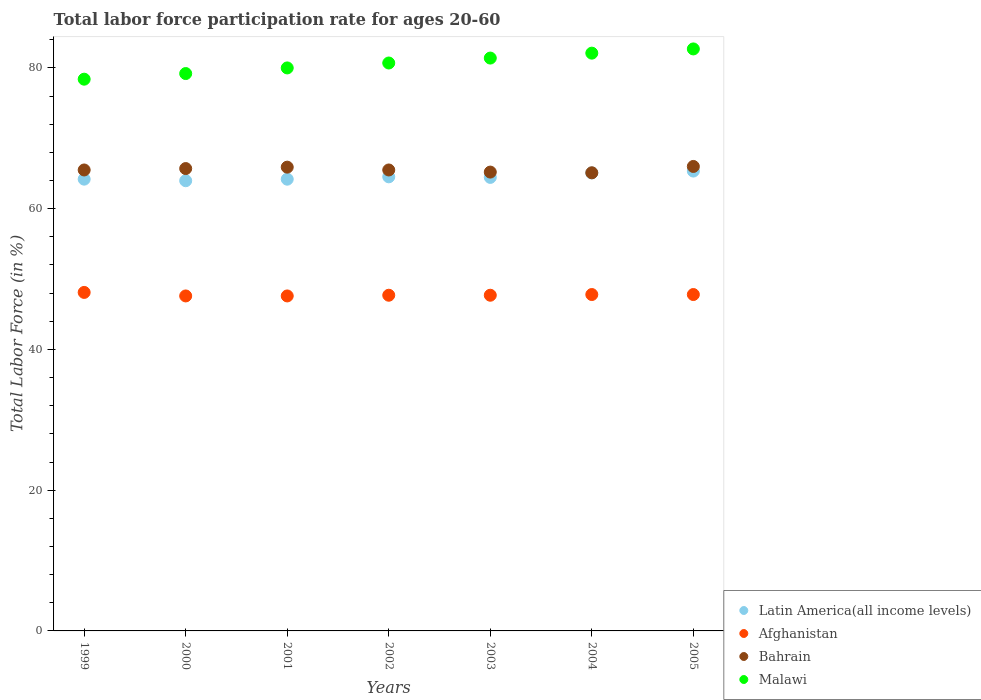How many different coloured dotlines are there?
Offer a very short reply. 4. Is the number of dotlines equal to the number of legend labels?
Your answer should be compact. Yes. What is the labor force participation rate in Bahrain in 2003?
Ensure brevity in your answer.  65.2. Across all years, what is the maximum labor force participation rate in Afghanistan?
Your response must be concise. 48.1. Across all years, what is the minimum labor force participation rate in Bahrain?
Make the answer very short. 65.1. In which year was the labor force participation rate in Latin America(all income levels) maximum?
Keep it short and to the point. 2005. In which year was the labor force participation rate in Malawi minimum?
Provide a short and direct response. 1999. What is the total labor force participation rate in Bahrain in the graph?
Your answer should be compact. 458.9. What is the difference between the labor force participation rate in Bahrain in 1999 and that in 2004?
Offer a very short reply. 0.4. What is the difference between the labor force participation rate in Malawi in 2004 and the labor force participation rate in Bahrain in 2001?
Offer a very short reply. 16.2. What is the average labor force participation rate in Afghanistan per year?
Ensure brevity in your answer.  47.76. In the year 2001, what is the difference between the labor force participation rate in Latin America(all income levels) and labor force participation rate in Afghanistan?
Make the answer very short. 16.59. What is the ratio of the labor force participation rate in Malawi in 2003 to that in 2004?
Provide a short and direct response. 0.99. Is the difference between the labor force participation rate in Latin America(all income levels) in 2001 and 2002 greater than the difference between the labor force participation rate in Afghanistan in 2001 and 2002?
Offer a very short reply. No. What is the difference between the highest and the second highest labor force participation rate in Bahrain?
Provide a succinct answer. 0.1. In how many years, is the labor force participation rate in Latin America(all income levels) greater than the average labor force participation rate in Latin America(all income levels) taken over all years?
Your answer should be very brief. 2. Is the sum of the labor force participation rate in Malawi in 1999 and 2002 greater than the maximum labor force participation rate in Latin America(all income levels) across all years?
Provide a short and direct response. Yes. How many dotlines are there?
Provide a short and direct response. 4. Are the values on the major ticks of Y-axis written in scientific E-notation?
Give a very brief answer. No. Does the graph contain any zero values?
Your answer should be compact. No. Does the graph contain grids?
Make the answer very short. No. How many legend labels are there?
Provide a short and direct response. 4. What is the title of the graph?
Your response must be concise. Total labor force participation rate for ages 20-60. Does "Ghana" appear as one of the legend labels in the graph?
Your answer should be compact. No. What is the label or title of the Y-axis?
Make the answer very short. Total Labor Force (in %). What is the Total Labor Force (in %) of Latin America(all income levels) in 1999?
Your answer should be compact. 64.19. What is the Total Labor Force (in %) in Afghanistan in 1999?
Keep it short and to the point. 48.1. What is the Total Labor Force (in %) in Bahrain in 1999?
Your answer should be compact. 65.5. What is the Total Labor Force (in %) in Malawi in 1999?
Your response must be concise. 78.4. What is the Total Labor Force (in %) in Latin America(all income levels) in 2000?
Provide a succinct answer. 63.97. What is the Total Labor Force (in %) in Afghanistan in 2000?
Your answer should be compact. 47.6. What is the Total Labor Force (in %) of Bahrain in 2000?
Your answer should be compact. 65.7. What is the Total Labor Force (in %) in Malawi in 2000?
Keep it short and to the point. 79.2. What is the Total Labor Force (in %) in Latin America(all income levels) in 2001?
Your answer should be compact. 64.19. What is the Total Labor Force (in %) of Afghanistan in 2001?
Give a very brief answer. 47.6. What is the Total Labor Force (in %) in Bahrain in 2001?
Your response must be concise. 65.9. What is the Total Labor Force (in %) in Malawi in 2001?
Provide a succinct answer. 80. What is the Total Labor Force (in %) in Latin America(all income levels) in 2002?
Ensure brevity in your answer.  64.53. What is the Total Labor Force (in %) of Afghanistan in 2002?
Make the answer very short. 47.7. What is the Total Labor Force (in %) of Bahrain in 2002?
Your answer should be compact. 65.5. What is the Total Labor Force (in %) of Malawi in 2002?
Ensure brevity in your answer.  80.7. What is the Total Labor Force (in %) of Latin America(all income levels) in 2003?
Your answer should be very brief. 64.44. What is the Total Labor Force (in %) in Afghanistan in 2003?
Your answer should be very brief. 47.7. What is the Total Labor Force (in %) of Bahrain in 2003?
Ensure brevity in your answer.  65.2. What is the Total Labor Force (in %) in Malawi in 2003?
Ensure brevity in your answer.  81.4. What is the Total Labor Force (in %) of Latin America(all income levels) in 2004?
Provide a succinct answer. 65.08. What is the Total Labor Force (in %) of Afghanistan in 2004?
Offer a very short reply. 47.8. What is the Total Labor Force (in %) in Bahrain in 2004?
Ensure brevity in your answer.  65.1. What is the Total Labor Force (in %) in Malawi in 2004?
Your response must be concise. 82.1. What is the Total Labor Force (in %) of Latin America(all income levels) in 2005?
Your response must be concise. 65.34. What is the Total Labor Force (in %) in Afghanistan in 2005?
Keep it short and to the point. 47.8. What is the Total Labor Force (in %) of Malawi in 2005?
Give a very brief answer. 82.7. Across all years, what is the maximum Total Labor Force (in %) in Latin America(all income levels)?
Keep it short and to the point. 65.34. Across all years, what is the maximum Total Labor Force (in %) in Afghanistan?
Offer a very short reply. 48.1. Across all years, what is the maximum Total Labor Force (in %) of Bahrain?
Make the answer very short. 66. Across all years, what is the maximum Total Labor Force (in %) in Malawi?
Offer a terse response. 82.7. Across all years, what is the minimum Total Labor Force (in %) in Latin America(all income levels)?
Make the answer very short. 63.97. Across all years, what is the minimum Total Labor Force (in %) in Afghanistan?
Offer a very short reply. 47.6. Across all years, what is the minimum Total Labor Force (in %) in Bahrain?
Provide a short and direct response. 65.1. Across all years, what is the minimum Total Labor Force (in %) of Malawi?
Offer a very short reply. 78.4. What is the total Total Labor Force (in %) of Latin America(all income levels) in the graph?
Provide a succinct answer. 451.75. What is the total Total Labor Force (in %) in Afghanistan in the graph?
Give a very brief answer. 334.3. What is the total Total Labor Force (in %) in Bahrain in the graph?
Provide a succinct answer. 458.9. What is the total Total Labor Force (in %) of Malawi in the graph?
Offer a very short reply. 564.5. What is the difference between the Total Labor Force (in %) in Latin America(all income levels) in 1999 and that in 2000?
Keep it short and to the point. 0.22. What is the difference between the Total Labor Force (in %) of Latin America(all income levels) in 1999 and that in 2001?
Offer a very short reply. 0. What is the difference between the Total Labor Force (in %) of Bahrain in 1999 and that in 2001?
Your response must be concise. -0.4. What is the difference between the Total Labor Force (in %) of Malawi in 1999 and that in 2001?
Your response must be concise. -1.6. What is the difference between the Total Labor Force (in %) of Latin America(all income levels) in 1999 and that in 2002?
Offer a terse response. -0.33. What is the difference between the Total Labor Force (in %) in Bahrain in 1999 and that in 2002?
Your response must be concise. 0. What is the difference between the Total Labor Force (in %) of Malawi in 1999 and that in 2002?
Keep it short and to the point. -2.3. What is the difference between the Total Labor Force (in %) of Latin America(all income levels) in 1999 and that in 2003?
Give a very brief answer. -0.25. What is the difference between the Total Labor Force (in %) in Bahrain in 1999 and that in 2003?
Your response must be concise. 0.3. What is the difference between the Total Labor Force (in %) of Latin America(all income levels) in 1999 and that in 2004?
Make the answer very short. -0.88. What is the difference between the Total Labor Force (in %) in Bahrain in 1999 and that in 2004?
Your answer should be compact. 0.4. What is the difference between the Total Labor Force (in %) in Malawi in 1999 and that in 2004?
Your answer should be very brief. -3.7. What is the difference between the Total Labor Force (in %) in Latin America(all income levels) in 1999 and that in 2005?
Offer a terse response. -1.15. What is the difference between the Total Labor Force (in %) in Afghanistan in 1999 and that in 2005?
Make the answer very short. 0.3. What is the difference between the Total Labor Force (in %) of Bahrain in 1999 and that in 2005?
Your response must be concise. -0.5. What is the difference between the Total Labor Force (in %) of Malawi in 1999 and that in 2005?
Provide a short and direct response. -4.3. What is the difference between the Total Labor Force (in %) in Latin America(all income levels) in 2000 and that in 2001?
Offer a very short reply. -0.22. What is the difference between the Total Labor Force (in %) of Latin America(all income levels) in 2000 and that in 2002?
Give a very brief answer. -0.55. What is the difference between the Total Labor Force (in %) of Afghanistan in 2000 and that in 2002?
Provide a succinct answer. -0.1. What is the difference between the Total Labor Force (in %) of Bahrain in 2000 and that in 2002?
Your answer should be very brief. 0.2. What is the difference between the Total Labor Force (in %) of Malawi in 2000 and that in 2002?
Your response must be concise. -1.5. What is the difference between the Total Labor Force (in %) in Latin America(all income levels) in 2000 and that in 2003?
Offer a very short reply. -0.47. What is the difference between the Total Labor Force (in %) of Bahrain in 2000 and that in 2003?
Give a very brief answer. 0.5. What is the difference between the Total Labor Force (in %) in Latin America(all income levels) in 2000 and that in 2004?
Provide a succinct answer. -1.1. What is the difference between the Total Labor Force (in %) in Latin America(all income levels) in 2000 and that in 2005?
Give a very brief answer. -1.37. What is the difference between the Total Labor Force (in %) in Afghanistan in 2000 and that in 2005?
Make the answer very short. -0.2. What is the difference between the Total Labor Force (in %) of Bahrain in 2000 and that in 2005?
Your answer should be very brief. -0.3. What is the difference between the Total Labor Force (in %) in Latin America(all income levels) in 2001 and that in 2002?
Give a very brief answer. -0.34. What is the difference between the Total Labor Force (in %) in Afghanistan in 2001 and that in 2002?
Your response must be concise. -0.1. What is the difference between the Total Labor Force (in %) of Bahrain in 2001 and that in 2002?
Provide a short and direct response. 0.4. What is the difference between the Total Labor Force (in %) of Latin America(all income levels) in 2001 and that in 2003?
Give a very brief answer. -0.25. What is the difference between the Total Labor Force (in %) in Afghanistan in 2001 and that in 2003?
Your answer should be compact. -0.1. What is the difference between the Total Labor Force (in %) in Malawi in 2001 and that in 2003?
Your answer should be very brief. -1.4. What is the difference between the Total Labor Force (in %) in Latin America(all income levels) in 2001 and that in 2004?
Your response must be concise. -0.88. What is the difference between the Total Labor Force (in %) of Bahrain in 2001 and that in 2004?
Your answer should be very brief. 0.8. What is the difference between the Total Labor Force (in %) of Latin America(all income levels) in 2001 and that in 2005?
Keep it short and to the point. -1.15. What is the difference between the Total Labor Force (in %) in Afghanistan in 2001 and that in 2005?
Make the answer very short. -0.2. What is the difference between the Total Labor Force (in %) of Bahrain in 2001 and that in 2005?
Offer a terse response. -0.1. What is the difference between the Total Labor Force (in %) in Malawi in 2001 and that in 2005?
Provide a short and direct response. -2.7. What is the difference between the Total Labor Force (in %) of Latin America(all income levels) in 2002 and that in 2003?
Your answer should be very brief. 0.08. What is the difference between the Total Labor Force (in %) in Bahrain in 2002 and that in 2003?
Offer a terse response. 0.3. What is the difference between the Total Labor Force (in %) in Malawi in 2002 and that in 2003?
Offer a very short reply. -0.7. What is the difference between the Total Labor Force (in %) of Latin America(all income levels) in 2002 and that in 2004?
Your answer should be compact. -0.55. What is the difference between the Total Labor Force (in %) of Afghanistan in 2002 and that in 2004?
Your response must be concise. -0.1. What is the difference between the Total Labor Force (in %) in Bahrain in 2002 and that in 2004?
Provide a succinct answer. 0.4. What is the difference between the Total Labor Force (in %) of Malawi in 2002 and that in 2004?
Ensure brevity in your answer.  -1.4. What is the difference between the Total Labor Force (in %) in Latin America(all income levels) in 2002 and that in 2005?
Provide a succinct answer. -0.82. What is the difference between the Total Labor Force (in %) of Afghanistan in 2002 and that in 2005?
Your answer should be very brief. -0.1. What is the difference between the Total Labor Force (in %) of Bahrain in 2002 and that in 2005?
Your answer should be compact. -0.5. What is the difference between the Total Labor Force (in %) in Malawi in 2002 and that in 2005?
Your answer should be compact. -2. What is the difference between the Total Labor Force (in %) of Latin America(all income levels) in 2003 and that in 2004?
Make the answer very short. -0.63. What is the difference between the Total Labor Force (in %) in Afghanistan in 2003 and that in 2004?
Provide a succinct answer. -0.1. What is the difference between the Total Labor Force (in %) in Latin America(all income levels) in 2003 and that in 2005?
Provide a succinct answer. -0.9. What is the difference between the Total Labor Force (in %) in Afghanistan in 2003 and that in 2005?
Your response must be concise. -0.1. What is the difference between the Total Labor Force (in %) of Bahrain in 2003 and that in 2005?
Provide a succinct answer. -0.8. What is the difference between the Total Labor Force (in %) in Latin America(all income levels) in 2004 and that in 2005?
Keep it short and to the point. -0.27. What is the difference between the Total Labor Force (in %) of Bahrain in 2004 and that in 2005?
Your answer should be very brief. -0.9. What is the difference between the Total Labor Force (in %) in Malawi in 2004 and that in 2005?
Your answer should be very brief. -0.6. What is the difference between the Total Labor Force (in %) of Latin America(all income levels) in 1999 and the Total Labor Force (in %) of Afghanistan in 2000?
Keep it short and to the point. 16.59. What is the difference between the Total Labor Force (in %) of Latin America(all income levels) in 1999 and the Total Labor Force (in %) of Bahrain in 2000?
Offer a terse response. -1.51. What is the difference between the Total Labor Force (in %) of Latin America(all income levels) in 1999 and the Total Labor Force (in %) of Malawi in 2000?
Your answer should be compact. -15.01. What is the difference between the Total Labor Force (in %) of Afghanistan in 1999 and the Total Labor Force (in %) of Bahrain in 2000?
Offer a terse response. -17.6. What is the difference between the Total Labor Force (in %) of Afghanistan in 1999 and the Total Labor Force (in %) of Malawi in 2000?
Offer a terse response. -31.1. What is the difference between the Total Labor Force (in %) of Bahrain in 1999 and the Total Labor Force (in %) of Malawi in 2000?
Your answer should be compact. -13.7. What is the difference between the Total Labor Force (in %) in Latin America(all income levels) in 1999 and the Total Labor Force (in %) in Afghanistan in 2001?
Your answer should be very brief. 16.59. What is the difference between the Total Labor Force (in %) of Latin America(all income levels) in 1999 and the Total Labor Force (in %) of Bahrain in 2001?
Provide a short and direct response. -1.71. What is the difference between the Total Labor Force (in %) in Latin America(all income levels) in 1999 and the Total Labor Force (in %) in Malawi in 2001?
Offer a very short reply. -15.81. What is the difference between the Total Labor Force (in %) of Afghanistan in 1999 and the Total Labor Force (in %) of Bahrain in 2001?
Provide a short and direct response. -17.8. What is the difference between the Total Labor Force (in %) of Afghanistan in 1999 and the Total Labor Force (in %) of Malawi in 2001?
Offer a very short reply. -31.9. What is the difference between the Total Labor Force (in %) in Bahrain in 1999 and the Total Labor Force (in %) in Malawi in 2001?
Offer a very short reply. -14.5. What is the difference between the Total Labor Force (in %) in Latin America(all income levels) in 1999 and the Total Labor Force (in %) in Afghanistan in 2002?
Make the answer very short. 16.49. What is the difference between the Total Labor Force (in %) in Latin America(all income levels) in 1999 and the Total Labor Force (in %) in Bahrain in 2002?
Your answer should be compact. -1.31. What is the difference between the Total Labor Force (in %) in Latin America(all income levels) in 1999 and the Total Labor Force (in %) in Malawi in 2002?
Offer a terse response. -16.51. What is the difference between the Total Labor Force (in %) of Afghanistan in 1999 and the Total Labor Force (in %) of Bahrain in 2002?
Provide a succinct answer. -17.4. What is the difference between the Total Labor Force (in %) of Afghanistan in 1999 and the Total Labor Force (in %) of Malawi in 2002?
Your answer should be very brief. -32.6. What is the difference between the Total Labor Force (in %) in Bahrain in 1999 and the Total Labor Force (in %) in Malawi in 2002?
Offer a very short reply. -15.2. What is the difference between the Total Labor Force (in %) of Latin America(all income levels) in 1999 and the Total Labor Force (in %) of Afghanistan in 2003?
Ensure brevity in your answer.  16.49. What is the difference between the Total Labor Force (in %) in Latin America(all income levels) in 1999 and the Total Labor Force (in %) in Bahrain in 2003?
Offer a very short reply. -1.01. What is the difference between the Total Labor Force (in %) in Latin America(all income levels) in 1999 and the Total Labor Force (in %) in Malawi in 2003?
Your response must be concise. -17.21. What is the difference between the Total Labor Force (in %) of Afghanistan in 1999 and the Total Labor Force (in %) of Bahrain in 2003?
Provide a short and direct response. -17.1. What is the difference between the Total Labor Force (in %) of Afghanistan in 1999 and the Total Labor Force (in %) of Malawi in 2003?
Make the answer very short. -33.3. What is the difference between the Total Labor Force (in %) in Bahrain in 1999 and the Total Labor Force (in %) in Malawi in 2003?
Your response must be concise. -15.9. What is the difference between the Total Labor Force (in %) of Latin America(all income levels) in 1999 and the Total Labor Force (in %) of Afghanistan in 2004?
Offer a terse response. 16.39. What is the difference between the Total Labor Force (in %) in Latin America(all income levels) in 1999 and the Total Labor Force (in %) in Bahrain in 2004?
Your answer should be compact. -0.91. What is the difference between the Total Labor Force (in %) in Latin America(all income levels) in 1999 and the Total Labor Force (in %) in Malawi in 2004?
Ensure brevity in your answer.  -17.91. What is the difference between the Total Labor Force (in %) of Afghanistan in 1999 and the Total Labor Force (in %) of Malawi in 2004?
Your answer should be compact. -34. What is the difference between the Total Labor Force (in %) in Bahrain in 1999 and the Total Labor Force (in %) in Malawi in 2004?
Keep it short and to the point. -16.6. What is the difference between the Total Labor Force (in %) of Latin America(all income levels) in 1999 and the Total Labor Force (in %) of Afghanistan in 2005?
Provide a short and direct response. 16.39. What is the difference between the Total Labor Force (in %) in Latin America(all income levels) in 1999 and the Total Labor Force (in %) in Bahrain in 2005?
Provide a short and direct response. -1.81. What is the difference between the Total Labor Force (in %) of Latin America(all income levels) in 1999 and the Total Labor Force (in %) of Malawi in 2005?
Ensure brevity in your answer.  -18.51. What is the difference between the Total Labor Force (in %) of Afghanistan in 1999 and the Total Labor Force (in %) of Bahrain in 2005?
Make the answer very short. -17.9. What is the difference between the Total Labor Force (in %) of Afghanistan in 1999 and the Total Labor Force (in %) of Malawi in 2005?
Give a very brief answer. -34.6. What is the difference between the Total Labor Force (in %) in Bahrain in 1999 and the Total Labor Force (in %) in Malawi in 2005?
Provide a short and direct response. -17.2. What is the difference between the Total Labor Force (in %) of Latin America(all income levels) in 2000 and the Total Labor Force (in %) of Afghanistan in 2001?
Provide a short and direct response. 16.37. What is the difference between the Total Labor Force (in %) of Latin America(all income levels) in 2000 and the Total Labor Force (in %) of Bahrain in 2001?
Your response must be concise. -1.93. What is the difference between the Total Labor Force (in %) of Latin America(all income levels) in 2000 and the Total Labor Force (in %) of Malawi in 2001?
Your answer should be very brief. -16.03. What is the difference between the Total Labor Force (in %) in Afghanistan in 2000 and the Total Labor Force (in %) in Bahrain in 2001?
Keep it short and to the point. -18.3. What is the difference between the Total Labor Force (in %) in Afghanistan in 2000 and the Total Labor Force (in %) in Malawi in 2001?
Provide a short and direct response. -32.4. What is the difference between the Total Labor Force (in %) of Bahrain in 2000 and the Total Labor Force (in %) of Malawi in 2001?
Your response must be concise. -14.3. What is the difference between the Total Labor Force (in %) of Latin America(all income levels) in 2000 and the Total Labor Force (in %) of Afghanistan in 2002?
Offer a very short reply. 16.27. What is the difference between the Total Labor Force (in %) of Latin America(all income levels) in 2000 and the Total Labor Force (in %) of Bahrain in 2002?
Provide a short and direct response. -1.53. What is the difference between the Total Labor Force (in %) in Latin America(all income levels) in 2000 and the Total Labor Force (in %) in Malawi in 2002?
Your answer should be very brief. -16.73. What is the difference between the Total Labor Force (in %) in Afghanistan in 2000 and the Total Labor Force (in %) in Bahrain in 2002?
Provide a short and direct response. -17.9. What is the difference between the Total Labor Force (in %) in Afghanistan in 2000 and the Total Labor Force (in %) in Malawi in 2002?
Provide a short and direct response. -33.1. What is the difference between the Total Labor Force (in %) in Latin America(all income levels) in 2000 and the Total Labor Force (in %) in Afghanistan in 2003?
Your response must be concise. 16.27. What is the difference between the Total Labor Force (in %) in Latin America(all income levels) in 2000 and the Total Labor Force (in %) in Bahrain in 2003?
Ensure brevity in your answer.  -1.23. What is the difference between the Total Labor Force (in %) in Latin America(all income levels) in 2000 and the Total Labor Force (in %) in Malawi in 2003?
Give a very brief answer. -17.43. What is the difference between the Total Labor Force (in %) of Afghanistan in 2000 and the Total Labor Force (in %) of Bahrain in 2003?
Your response must be concise. -17.6. What is the difference between the Total Labor Force (in %) in Afghanistan in 2000 and the Total Labor Force (in %) in Malawi in 2003?
Your answer should be compact. -33.8. What is the difference between the Total Labor Force (in %) of Bahrain in 2000 and the Total Labor Force (in %) of Malawi in 2003?
Your answer should be compact. -15.7. What is the difference between the Total Labor Force (in %) in Latin America(all income levels) in 2000 and the Total Labor Force (in %) in Afghanistan in 2004?
Offer a very short reply. 16.17. What is the difference between the Total Labor Force (in %) in Latin America(all income levels) in 2000 and the Total Labor Force (in %) in Bahrain in 2004?
Provide a succinct answer. -1.13. What is the difference between the Total Labor Force (in %) in Latin America(all income levels) in 2000 and the Total Labor Force (in %) in Malawi in 2004?
Ensure brevity in your answer.  -18.13. What is the difference between the Total Labor Force (in %) in Afghanistan in 2000 and the Total Labor Force (in %) in Bahrain in 2004?
Offer a terse response. -17.5. What is the difference between the Total Labor Force (in %) in Afghanistan in 2000 and the Total Labor Force (in %) in Malawi in 2004?
Provide a succinct answer. -34.5. What is the difference between the Total Labor Force (in %) in Bahrain in 2000 and the Total Labor Force (in %) in Malawi in 2004?
Your answer should be compact. -16.4. What is the difference between the Total Labor Force (in %) of Latin America(all income levels) in 2000 and the Total Labor Force (in %) of Afghanistan in 2005?
Your answer should be compact. 16.17. What is the difference between the Total Labor Force (in %) of Latin America(all income levels) in 2000 and the Total Labor Force (in %) of Bahrain in 2005?
Give a very brief answer. -2.03. What is the difference between the Total Labor Force (in %) in Latin America(all income levels) in 2000 and the Total Labor Force (in %) in Malawi in 2005?
Keep it short and to the point. -18.73. What is the difference between the Total Labor Force (in %) of Afghanistan in 2000 and the Total Labor Force (in %) of Bahrain in 2005?
Make the answer very short. -18.4. What is the difference between the Total Labor Force (in %) of Afghanistan in 2000 and the Total Labor Force (in %) of Malawi in 2005?
Provide a succinct answer. -35.1. What is the difference between the Total Labor Force (in %) of Latin America(all income levels) in 2001 and the Total Labor Force (in %) of Afghanistan in 2002?
Keep it short and to the point. 16.49. What is the difference between the Total Labor Force (in %) in Latin America(all income levels) in 2001 and the Total Labor Force (in %) in Bahrain in 2002?
Make the answer very short. -1.31. What is the difference between the Total Labor Force (in %) in Latin America(all income levels) in 2001 and the Total Labor Force (in %) in Malawi in 2002?
Your answer should be very brief. -16.51. What is the difference between the Total Labor Force (in %) in Afghanistan in 2001 and the Total Labor Force (in %) in Bahrain in 2002?
Keep it short and to the point. -17.9. What is the difference between the Total Labor Force (in %) of Afghanistan in 2001 and the Total Labor Force (in %) of Malawi in 2002?
Your answer should be compact. -33.1. What is the difference between the Total Labor Force (in %) of Bahrain in 2001 and the Total Labor Force (in %) of Malawi in 2002?
Your response must be concise. -14.8. What is the difference between the Total Labor Force (in %) of Latin America(all income levels) in 2001 and the Total Labor Force (in %) of Afghanistan in 2003?
Offer a terse response. 16.49. What is the difference between the Total Labor Force (in %) of Latin America(all income levels) in 2001 and the Total Labor Force (in %) of Bahrain in 2003?
Keep it short and to the point. -1.01. What is the difference between the Total Labor Force (in %) of Latin America(all income levels) in 2001 and the Total Labor Force (in %) of Malawi in 2003?
Your answer should be compact. -17.21. What is the difference between the Total Labor Force (in %) in Afghanistan in 2001 and the Total Labor Force (in %) in Bahrain in 2003?
Give a very brief answer. -17.6. What is the difference between the Total Labor Force (in %) of Afghanistan in 2001 and the Total Labor Force (in %) of Malawi in 2003?
Keep it short and to the point. -33.8. What is the difference between the Total Labor Force (in %) in Bahrain in 2001 and the Total Labor Force (in %) in Malawi in 2003?
Keep it short and to the point. -15.5. What is the difference between the Total Labor Force (in %) of Latin America(all income levels) in 2001 and the Total Labor Force (in %) of Afghanistan in 2004?
Your response must be concise. 16.39. What is the difference between the Total Labor Force (in %) in Latin America(all income levels) in 2001 and the Total Labor Force (in %) in Bahrain in 2004?
Offer a terse response. -0.91. What is the difference between the Total Labor Force (in %) of Latin America(all income levels) in 2001 and the Total Labor Force (in %) of Malawi in 2004?
Offer a terse response. -17.91. What is the difference between the Total Labor Force (in %) of Afghanistan in 2001 and the Total Labor Force (in %) of Bahrain in 2004?
Keep it short and to the point. -17.5. What is the difference between the Total Labor Force (in %) in Afghanistan in 2001 and the Total Labor Force (in %) in Malawi in 2004?
Ensure brevity in your answer.  -34.5. What is the difference between the Total Labor Force (in %) in Bahrain in 2001 and the Total Labor Force (in %) in Malawi in 2004?
Provide a short and direct response. -16.2. What is the difference between the Total Labor Force (in %) of Latin America(all income levels) in 2001 and the Total Labor Force (in %) of Afghanistan in 2005?
Offer a terse response. 16.39. What is the difference between the Total Labor Force (in %) of Latin America(all income levels) in 2001 and the Total Labor Force (in %) of Bahrain in 2005?
Make the answer very short. -1.81. What is the difference between the Total Labor Force (in %) in Latin America(all income levels) in 2001 and the Total Labor Force (in %) in Malawi in 2005?
Your answer should be very brief. -18.51. What is the difference between the Total Labor Force (in %) in Afghanistan in 2001 and the Total Labor Force (in %) in Bahrain in 2005?
Keep it short and to the point. -18.4. What is the difference between the Total Labor Force (in %) in Afghanistan in 2001 and the Total Labor Force (in %) in Malawi in 2005?
Provide a short and direct response. -35.1. What is the difference between the Total Labor Force (in %) in Bahrain in 2001 and the Total Labor Force (in %) in Malawi in 2005?
Your response must be concise. -16.8. What is the difference between the Total Labor Force (in %) in Latin America(all income levels) in 2002 and the Total Labor Force (in %) in Afghanistan in 2003?
Make the answer very short. 16.83. What is the difference between the Total Labor Force (in %) in Latin America(all income levels) in 2002 and the Total Labor Force (in %) in Bahrain in 2003?
Make the answer very short. -0.67. What is the difference between the Total Labor Force (in %) of Latin America(all income levels) in 2002 and the Total Labor Force (in %) of Malawi in 2003?
Provide a succinct answer. -16.87. What is the difference between the Total Labor Force (in %) in Afghanistan in 2002 and the Total Labor Force (in %) in Bahrain in 2003?
Provide a succinct answer. -17.5. What is the difference between the Total Labor Force (in %) of Afghanistan in 2002 and the Total Labor Force (in %) of Malawi in 2003?
Ensure brevity in your answer.  -33.7. What is the difference between the Total Labor Force (in %) of Bahrain in 2002 and the Total Labor Force (in %) of Malawi in 2003?
Your response must be concise. -15.9. What is the difference between the Total Labor Force (in %) of Latin America(all income levels) in 2002 and the Total Labor Force (in %) of Afghanistan in 2004?
Ensure brevity in your answer.  16.73. What is the difference between the Total Labor Force (in %) in Latin America(all income levels) in 2002 and the Total Labor Force (in %) in Bahrain in 2004?
Keep it short and to the point. -0.57. What is the difference between the Total Labor Force (in %) of Latin America(all income levels) in 2002 and the Total Labor Force (in %) of Malawi in 2004?
Give a very brief answer. -17.57. What is the difference between the Total Labor Force (in %) in Afghanistan in 2002 and the Total Labor Force (in %) in Bahrain in 2004?
Provide a succinct answer. -17.4. What is the difference between the Total Labor Force (in %) of Afghanistan in 2002 and the Total Labor Force (in %) of Malawi in 2004?
Your answer should be compact. -34.4. What is the difference between the Total Labor Force (in %) in Bahrain in 2002 and the Total Labor Force (in %) in Malawi in 2004?
Give a very brief answer. -16.6. What is the difference between the Total Labor Force (in %) of Latin America(all income levels) in 2002 and the Total Labor Force (in %) of Afghanistan in 2005?
Your answer should be very brief. 16.73. What is the difference between the Total Labor Force (in %) in Latin America(all income levels) in 2002 and the Total Labor Force (in %) in Bahrain in 2005?
Offer a terse response. -1.47. What is the difference between the Total Labor Force (in %) in Latin America(all income levels) in 2002 and the Total Labor Force (in %) in Malawi in 2005?
Offer a terse response. -18.17. What is the difference between the Total Labor Force (in %) of Afghanistan in 2002 and the Total Labor Force (in %) of Bahrain in 2005?
Keep it short and to the point. -18.3. What is the difference between the Total Labor Force (in %) in Afghanistan in 2002 and the Total Labor Force (in %) in Malawi in 2005?
Your answer should be compact. -35. What is the difference between the Total Labor Force (in %) in Bahrain in 2002 and the Total Labor Force (in %) in Malawi in 2005?
Ensure brevity in your answer.  -17.2. What is the difference between the Total Labor Force (in %) of Latin America(all income levels) in 2003 and the Total Labor Force (in %) of Afghanistan in 2004?
Provide a succinct answer. 16.64. What is the difference between the Total Labor Force (in %) in Latin America(all income levels) in 2003 and the Total Labor Force (in %) in Bahrain in 2004?
Offer a very short reply. -0.66. What is the difference between the Total Labor Force (in %) of Latin America(all income levels) in 2003 and the Total Labor Force (in %) of Malawi in 2004?
Keep it short and to the point. -17.66. What is the difference between the Total Labor Force (in %) of Afghanistan in 2003 and the Total Labor Force (in %) of Bahrain in 2004?
Provide a succinct answer. -17.4. What is the difference between the Total Labor Force (in %) in Afghanistan in 2003 and the Total Labor Force (in %) in Malawi in 2004?
Offer a very short reply. -34.4. What is the difference between the Total Labor Force (in %) in Bahrain in 2003 and the Total Labor Force (in %) in Malawi in 2004?
Provide a succinct answer. -16.9. What is the difference between the Total Labor Force (in %) in Latin America(all income levels) in 2003 and the Total Labor Force (in %) in Afghanistan in 2005?
Your answer should be compact. 16.64. What is the difference between the Total Labor Force (in %) of Latin America(all income levels) in 2003 and the Total Labor Force (in %) of Bahrain in 2005?
Offer a very short reply. -1.56. What is the difference between the Total Labor Force (in %) in Latin America(all income levels) in 2003 and the Total Labor Force (in %) in Malawi in 2005?
Provide a succinct answer. -18.26. What is the difference between the Total Labor Force (in %) of Afghanistan in 2003 and the Total Labor Force (in %) of Bahrain in 2005?
Make the answer very short. -18.3. What is the difference between the Total Labor Force (in %) of Afghanistan in 2003 and the Total Labor Force (in %) of Malawi in 2005?
Offer a terse response. -35. What is the difference between the Total Labor Force (in %) of Bahrain in 2003 and the Total Labor Force (in %) of Malawi in 2005?
Offer a terse response. -17.5. What is the difference between the Total Labor Force (in %) of Latin America(all income levels) in 2004 and the Total Labor Force (in %) of Afghanistan in 2005?
Provide a short and direct response. 17.28. What is the difference between the Total Labor Force (in %) in Latin America(all income levels) in 2004 and the Total Labor Force (in %) in Bahrain in 2005?
Provide a succinct answer. -0.92. What is the difference between the Total Labor Force (in %) of Latin America(all income levels) in 2004 and the Total Labor Force (in %) of Malawi in 2005?
Provide a succinct answer. -17.62. What is the difference between the Total Labor Force (in %) in Afghanistan in 2004 and the Total Labor Force (in %) in Bahrain in 2005?
Your response must be concise. -18.2. What is the difference between the Total Labor Force (in %) in Afghanistan in 2004 and the Total Labor Force (in %) in Malawi in 2005?
Offer a terse response. -34.9. What is the difference between the Total Labor Force (in %) of Bahrain in 2004 and the Total Labor Force (in %) of Malawi in 2005?
Provide a succinct answer. -17.6. What is the average Total Labor Force (in %) in Latin America(all income levels) per year?
Offer a terse response. 64.54. What is the average Total Labor Force (in %) in Afghanistan per year?
Keep it short and to the point. 47.76. What is the average Total Labor Force (in %) in Bahrain per year?
Your answer should be very brief. 65.56. What is the average Total Labor Force (in %) of Malawi per year?
Your answer should be very brief. 80.64. In the year 1999, what is the difference between the Total Labor Force (in %) in Latin America(all income levels) and Total Labor Force (in %) in Afghanistan?
Your answer should be compact. 16.09. In the year 1999, what is the difference between the Total Labor Force (in %) in Latin America(all income levels) and Total Labor Force (in %) in Bahrain?
Make the answer very short. -1.31. In the year 1999, what is the difference between the Total Labor Force (in %) in Latin America(all income levels) and Total Labor Force (in %) in Malawi?
Your answer should be very brief. -14.21. In the year 1999, what is the difference between the Total Labor Force (in %) in Afghanistan and Total Labor Force (in %) in Bahrain?
Your answer should be very brief. -17.4. In the year 1999, what is the difference between the Total Labor Force (in %) of Afghanistan and Total Labor Force (in %) of Malawi?
Provide a short and direct response. -30.3. In the year 2000, what is the difference between the Total Labor Force (in %) of Latin America(all income levels) and Total Labor Force (in %) of Afghanistan?
Make the answer very short. 16.37. In the year 2000, what is the difference between the Total Labor Force (in %) of Latin America(all income levels) and Total Labor Force (in %) of Bahrain?
Keep it short and to the point. -1.73. In the year 2000, what is the difference between the Total Labor Force (in %) in Latin America(all income levels) and Total Labor Force (in %) in Malawi?
Provide a succinct answer. -15.23. In the year 2000, what is the difference between the Total Labor Force (in %) of Afghanistan and Total Labor Force (in %) of Bahrain?
Keep it short and to the point. -18.1. In the year 2000, what is the difference between the Total Labor Force (in %) of Afghanistan and Total Labor Force (in %) of Malawi?
Your answer should be very brief. -31.6. In the year 2001, what is the difference between the Total Labor Force (in %) in Latin America(all income levels) and Total Labor Force (in %) in Afghanistan?
Your answer should be very brief. 16.59. In the year 2001, what is the difference between the Total Labor Force (in %) of Latin America(all income levels) and Total Labor Force (in %) of Bahrain?
Keep it short and to the point. -1.71. In the year 2001, what is the difference between the Total Labor Force (in %) in Latin America(all income levels) and Total Labor Force (in %) in Malawi?
Offer a terse response. -15.81. In the year 2001, what is the difference between the Total Labor Force (in %) in Afghanistan and Total Labor Force (in %) in Bahrain?
Provide a succinct answer. -18.3. In the year 2001, what is the difference between the Total Labor Force (in %) of Afghanistan and Total Labor Force (in %) of Malawi?
Your response must be concise. -32.4. In the year 2001, what is the difference between the Total Labor Force (in %) in Bahrain and Total Labor Force (in %) in Malawi?
Keep it short and to the point. -14.1. In the year 2002, what is the difference between the Total Labor Force (in %) in Latin America(all income levels) and Total Labor Force (in %) in Afghanistan?
Make the answer very short. 16.83. In the year 2002, what is the difference between the Total Labor Force (in %) of Latin America(all income levels) and Total Labor Force (in %) of Bahrain?
Provide a short and direct response. -0.97. In the year 2002, what is the difference between the Total Labor Force (in %) of Latin America(all income levels) and Total Labor Force (in %) of Malawi?
Your response must be concise. -16.17. In the year 2002, what is the difference between the Total Labor Force (in %) in Afghanistan and Total Labor Force (in %) in Bahrain?
Your response must be concise. -17.8. In the year 2002, what is the difference between the Total Labor Force (in %) in Afghanistan and Total Labor Force (in %) in Malawi?
Your answer should be compact. -33. In the year 2002, what is the difference between the Total Labor Force (in %) of Bahrain and Total Labor Force (in %) of Malawi?
Your answer should be very brief. -15.2. In the year 2003, what is the difference between the Total Labor Force (in %) of Latin America(all income levels) and Total Labor Force (in %) of Afghanistan?
Provide a short and direct response. 16.74. In the year 2003, what is the difference between the Total Labor Force (in %) of Latin America(all income levels) and Total Labor Force (in %) of Bahrain?
Make the answer very short. -0.76. In the year 2003, what is the difference between the Total Labor Force (in %) in Latin America(all income levels) and Total Labor Force (in %) in Malawi?
Your answer should be compact. -16.96. In the year 2003, what is the difference between the Total Labor Force (in %) of Afghanistan and Total Labor Force (in %) of Bahrain?
Your answer should be very brief. -17.5. In the year 2003, what is the difference between the Total Labor Force (in %) of Afghanistan and Total Labor Force (in %) of Malawi?
Give a very brief answer. -33.7. In the year 2003, what is the difference between the Total Labor Force (in %) in Bahrain and Total Labor Force (in %) in Malawi?
Give a very brief answer. -16.2. In the year 2004, what is the difference between the Total Labor Force (in %) of Latin America(all income levels) and Total Labor Force (in %) of Afghanistan?
Keep it short and to the point. 17.28. In the year 2004, what is the difference between the Total Labor Force (in %) of Latin America(all income levels) and Total Labor Force (in %) of Bahrain?
Offer a terse response. -0.02. In the year 2004, what is the difference between the Total Labor Force (in %) of Latin America(all income levels) and Total Labor Force (in %) of Malawi?
Provide a succinct answer. -17.02. In the year 2004, what is the difference between the Total Labor Force (in %) of Afghanistan and Total Labor Force (in %) of Bahrain?
Your answer should be very brief. -17.3. In the year 2004, what is the difference between the Total Labor Force (in %) in Afghanistan and Total Labor Force (in %) in Malawi?
Give a very brief answer. -34.3. In the year 2004, what is the difference between the Total Labor Force (in %) of Bahrain and Total Labor Force (in %) of Malawi?
Offer a very short reply. -17. In the year 2005, what is the difference between the Total Labor Force (in %) in Latin America(all income levels) and Total Labor Force (in %) in Afghanistan?
Your response must be concise. 17.54. In the year 2005, what is the difference between the Total Labor Force (in %) in Latin America(all income levels) and Total Labor Force (in %) in Bahrain?
Offer a very short reply. -0.66. In the year 2005, what is the difference between the Total Labor Force (in %) in Latin America(all income levels) and Total Labor Force (in %) in Malawi?
Make the answer very short. -17.36. In the year 2005, what is the difference between the Total Labor Force (in %) of Afghanistan and Total Labor Force (in %) of Bahrain?
Give a very brief answer. -18.2. In the year 2005, what is the difference between the Total Labor Force (in %) in Afghanistan and Total Labor Force (in %) in Malawi?
Offer a very short reply. -34.9. In the year 2005, what is the difference between the Total Labor Force (in %) in Bahrain and Total Labor Force (in %) in Malawi?
Ensure brevity in your answer.  -16.7. What is the ratio of the Total Labor Force (in %) in Afghanistan in 1999 to that in 2000?
Offer a very short reply. 1.01. What is the ratio of the Total Labor Force (in %) of Latin America(all income levels) in 1999 to that in 2001?
Keep it short and to the point. 1. What is the ratio of the Total Labor Force (in %) of Afghanistan in 1999 to that in 2001?
Give a very brief answer. 1.01. What is the ratio of the Total Labor Force (in %) in Bahrain in 1999 to that in 2001?
Keep it short and to the point. 0.99. What is the ratio of the Total Labor Force (in %) in Afghanistan in 1999 to that in 2002?
Your response must be concise. 1.01. What is the ratio of the Total Labor Force (in %) in Malawi in 1999 to that in 2002?
Your response must be concise. 0.97. What is the ratio of the Total Labor Force (in %) of Latin America(all income levels) in 1999 to that in 2003?
Your response must be concise. 1. What is the ratio of the Total Labor Force (in %) of Afghanistan in 1999 to that in 2003?
Offer a very short reply. 1.01. What is the ratio of the Total Labor Force (in %) of Malawi in 1999 to that in 2003?
Offer a very short reply. 0.96. What is the ratio of the Total Labor Force (in %) in Latin America(all income levels) in 1999 to that in 2004?
Make the answer very short. 0.99. What is the ratio of the Total Labor Force (in %) of Malawi in 1999 to that in 2004?
Make the answer very short. 0.95. What is the ratio of the Total Labor Force (in %) in Latin America(all income levels) in 1999 to that in 2005?
Your answer should be compact. 0.98. What is the ratio of the Total Labor Force (in %) in Afghanistan in 1999 to that in 2005?
Your answer should be compact. 1.01. What is the ratio of the Total Labor Force (in %) of Bahrain in 1999 to that in 2005?
Your answer should be very brief. 0.99. What is the ratio of the Total Labor Force (in %) of Malawi in 1999 to that in 2005?
Give a very brief answer. 0.95. What is the ratio of the Total Labor Force (in %) in Latin America(all income levels) in 2000 to that in 2002?
Make the answer very short. 0.99. What is the ratio of the Total Labor Force (in %) of Afghanistan in 2000 to that in 2002?
Your answer should be very brief. 1. What is the ratio of the Total Labor Force (in %) in Malawi in 2000 to that in 2002?
Ensure brevity in your answer.  0.98. What is the ratio of the Total Labor Force (in %) of Bahrain in 2000 to that in 2003?
Provide a short and direct response. 1.01. What is the ratio of the Total Labor Force (in %) of Bahrain in 2000 to that in 2004?
Offer a very short reply. 1.01. What is the ratio of the Total Labor Force (in %) in Malawi in 2000 to that in 2004?
Make the answer very short. 0.96. What is the ratio of the Total Labor Force (in %) of Malawi in 2000 to that in 2005?
Offer a terse response. 0.96. What is the ratio of the Total Labor Force (in %) in Latin America(all income levels) in 2001 to that in 2002?
Ensure brevity in your answer.  0.99. What is the ratio of the Total Labor Force (in %) of Afghanistan in 2001 to that in 2002?
Give a very brief answer. 1. What is the ratio of the Total Labor Force (in %) in Bahrain in 2001 to that in 2002?
Provide a succinct answer. 1.01. What is the ratio of the Total Labor Force (in %) in Malawi in 2001 to that in 2002?
Your answer should be compact. 0.99. What is the ratio of the Total Labor Force (in %) in Bahrain in 2001 to that in 2003?
Provide a succinct answer. 1.01. What is the ratio of the Total Labor Force (in %) of Malawi in 2001 to that in 2003?
Provide a short and direct response. 0.98. What is the ratio of the Total Labor Force (in %) of Latin America(all income levels) in 2001 to that in 2004?
Offer a terse response. 0.99. What is the ratio of the Total Labor Force (in %) of Afghanistan in 2001 to that in 2004?
Provide a short and direct response. 1. What is the ratio of the Total Labor Force (in %) in Bahrain in 2001 to that in 2004?
Your answer should be compact. 1.01. What is the ratio of the Total Labor Force (in %) of Malawi in 2001 to that in 2004?
Your answer should be very brief. 0.97. What is the ratio of the Total Labor Force (in %) in Latin America(all income levels) in 2001 to that in 2005?
Provide a short and direct response. 0.98. What is the ratio of the Total Labor Force (in %) of Malawi in 2001 to that in 2005?
Your response must be concise. 0.97. What is the ratio of the Total Labor Force (in %) in Afghanistan in 2002 to that in 2003?
Your answer should be very brief. 1. What is the ratio of the Total Labor Force (in %) of Bahrain in 2002 to that in 2003?
Provide a short and direct response. 1. What is the ratio of the Total Labor Force (in %) of Latin America(all income levels) in 2002 to that in 2004?
Your answer should be very brief. 0.99. What is the ratio of the Total Labor Force (in %) in Malawi in 2002 to that in 2004?
Provide a succinct answer. 0.98. What is the ratio of the Total Labor Force (in %) of Latin America(all income levels) in 2002 to that in 2005?
Your answer should be compact. 0.99. What is the ratio of the Total Labor Force (in %) in Malawi in 2002 to that in 2005?
Provide a short and direct response. 0.98. What is the ratio of the Total Labor Force (in %) of Latin America(all income levels) in 2003 to that in 2004?
Keep it short and to the point. 0.99. What is the ratio of the Total Labor Force (in %) in Afghanistan in 2003 to that in 2004?
Keep it short and to the point. 1. What is the ratio of the Total Labor Force (in %) in Bahrain in 2003 to that in 2004?
Your answer should be very brief. 1. What is the ratio of the Total Labor Force (in %) in Latin America(all income levels) in 2003 to that in 2005?
Offer a very short reply. 0.99. What is the ratio of the Total Labor Force (in %) of Afghanistan in 2003 to that in 2005?
Provide a succinct answer. 1. What is the ratio of the Total Labor Force (in %) of Bahrain in 2003 to that in 2005?
Give a very brief answer. 0.99. What is the ratio of the Total Labor Force (in %) of Malawi in 2003 to that in 2005?
Offer a very short reply. 0.98. What is the ratio of the Total Labor Force (in %) of Bahrain in 2004 to that in 2005?
Offer a terse response. 0.99. What is the difference between the highest and the second highest Total Labor Force (in %) in Latin America(all income levels)?
Ensure brevity in your answer.  0.27. What is the difference between the highest and the second highest Total Labor Force (in %) of Afghanistan?
Provide a short and direct response. 0.3. What is the difference between the highest and the second highest Total Labor Force (in %) of Bahrain?
Give a very brief answer. 0.1. What is the difference between the highest and the second highest Total Labor Force (in %) of Malawi?
Keep it short and to the point. 0.6. What is the difference between the highest and the lowest Total Labor Force (in %) of Latin America(all income levels)?
Offer a very short reply. 1.37. What is the difference between the highest and the lowest Total Labor Force (in %) of Afghanistan?
Ensure brevity in your answer.  0.5. What is the difference between the highest and the lowest Total Labor Force (in %) of Bahrain?
Provide a short and direct response. 0.9. What is the difference between the highest and the lowest Total Labor Force (in %) of Malawi?
Offer a terse response. 4.3. 